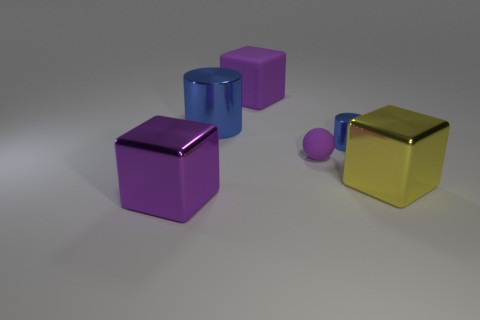There is a large purple cube that is right of the large metal cube on the left side of the large matte cube; what is it made of?
Your answer should be compact. Rubber. What material is the other big purple object that is the same shape as the purple shiny thing?
Your answer should be compact. Rubber. There is a metal thing that is in front of the yellow thing; is its size the same as the tiny metal thing?
Your response must be concise. No. What number of shiny objects are either cylinders or blue balls?
Make the answer very short. 2. What material is the block that is right of the big blue shiny thing and left of the tiny blue cylinder?
Offer a terse response. Rubber. Are the yellow block and the large blue object made of the same material?
Ensure brevity in your answer.  Yes. There is a shiny thing that is both behind the yellow metallic block and on the right side of the large blue thing; what size is it?
Ensure brevity in your answer.  Small. What is the shape of the big blue thing?
Ensure brevity in your answer.  Cylinder. What number of things are shiny cubes or shiny objects that are behind the purple metallic block?
Provide a short and direct response. 4. Do the cylinder that is on the right side of the large purple matte object and the ball have the same color?
Offer a very short reply. No. 